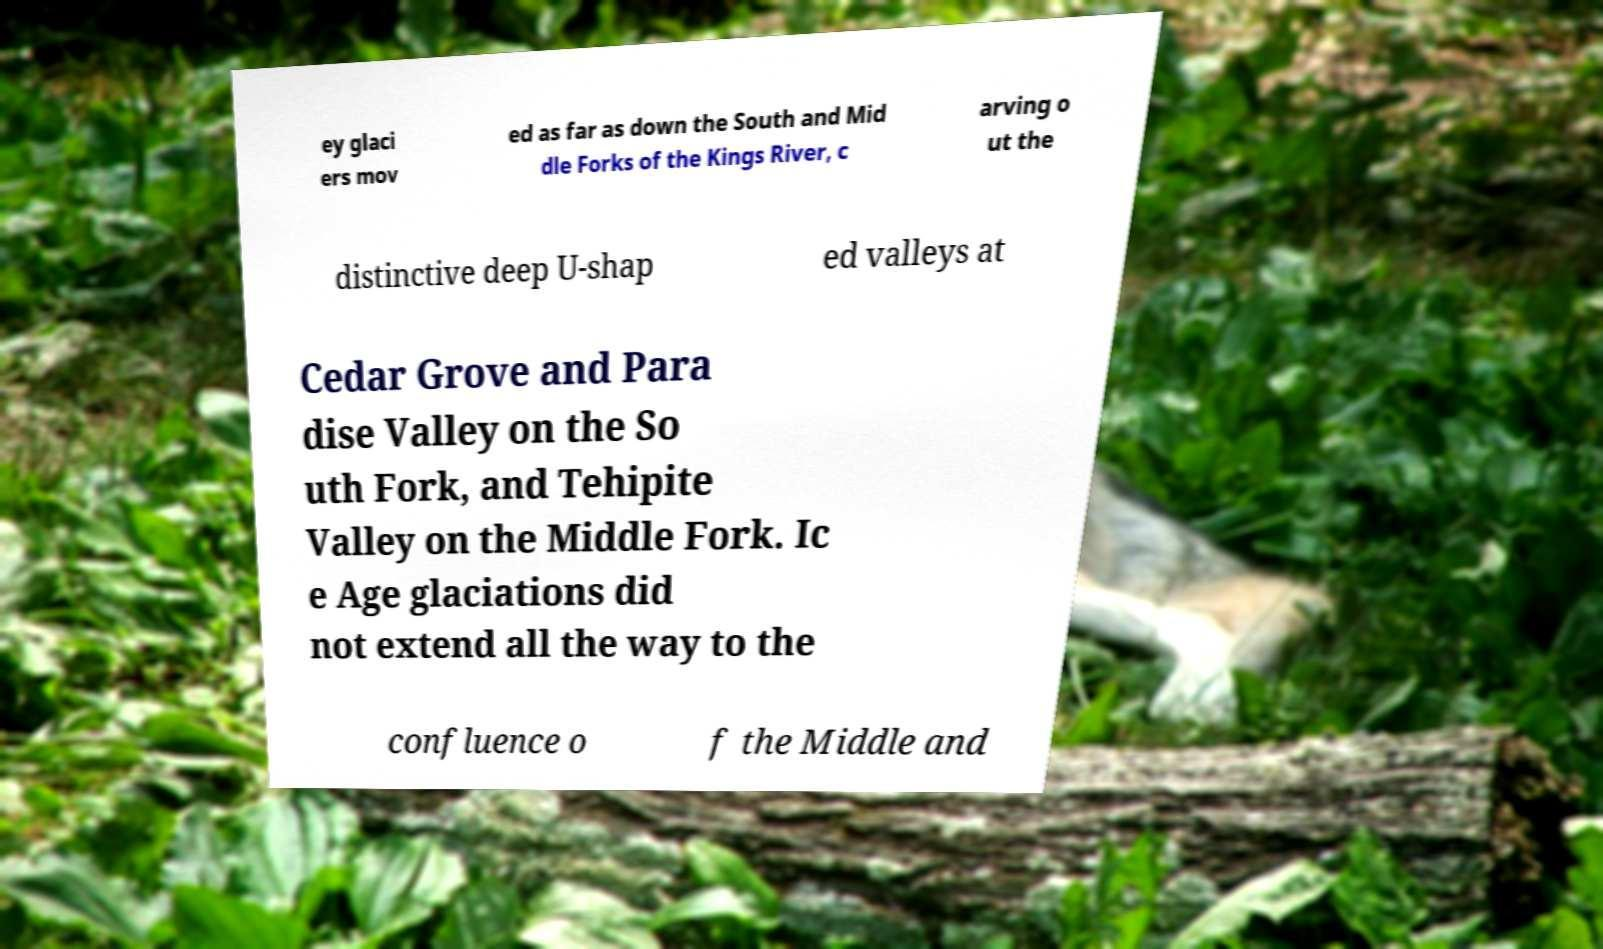Could you extract and type out the text from this image? ey glaci ers mov ed as far as down the South and Mid dle Forks of the Kings River, c arving o ut the distinctive deep U-shap ed valleys at Cedar Grove and Para dise Valley on the So uth Fork, and Tehipite Valley on the Middle Fork. Ic e Age glaciations did not extend all the way to the confluence o f the Middle and 